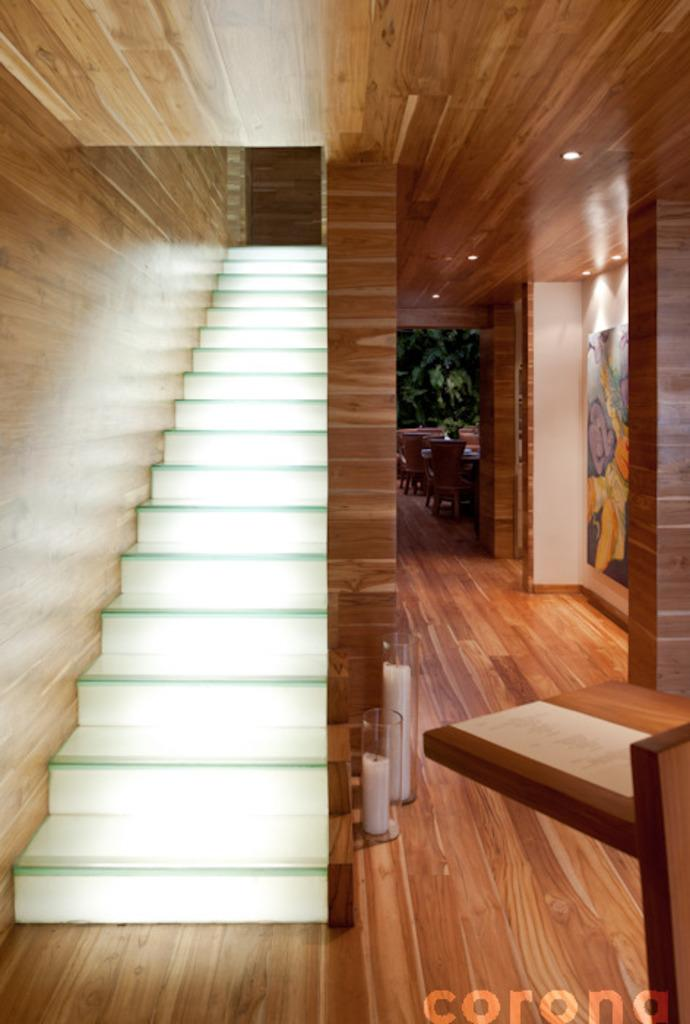What type of architectural feature can be seen in the image? There are stairs, candles, and pillars in the image. What is on the floor in the image? There are objects on the floor in the image. Can you describe any additional elements in the image? There is a watermark in the image. What type of music can be heard coming from the tank in the image? There is no tank or music present in the image. 